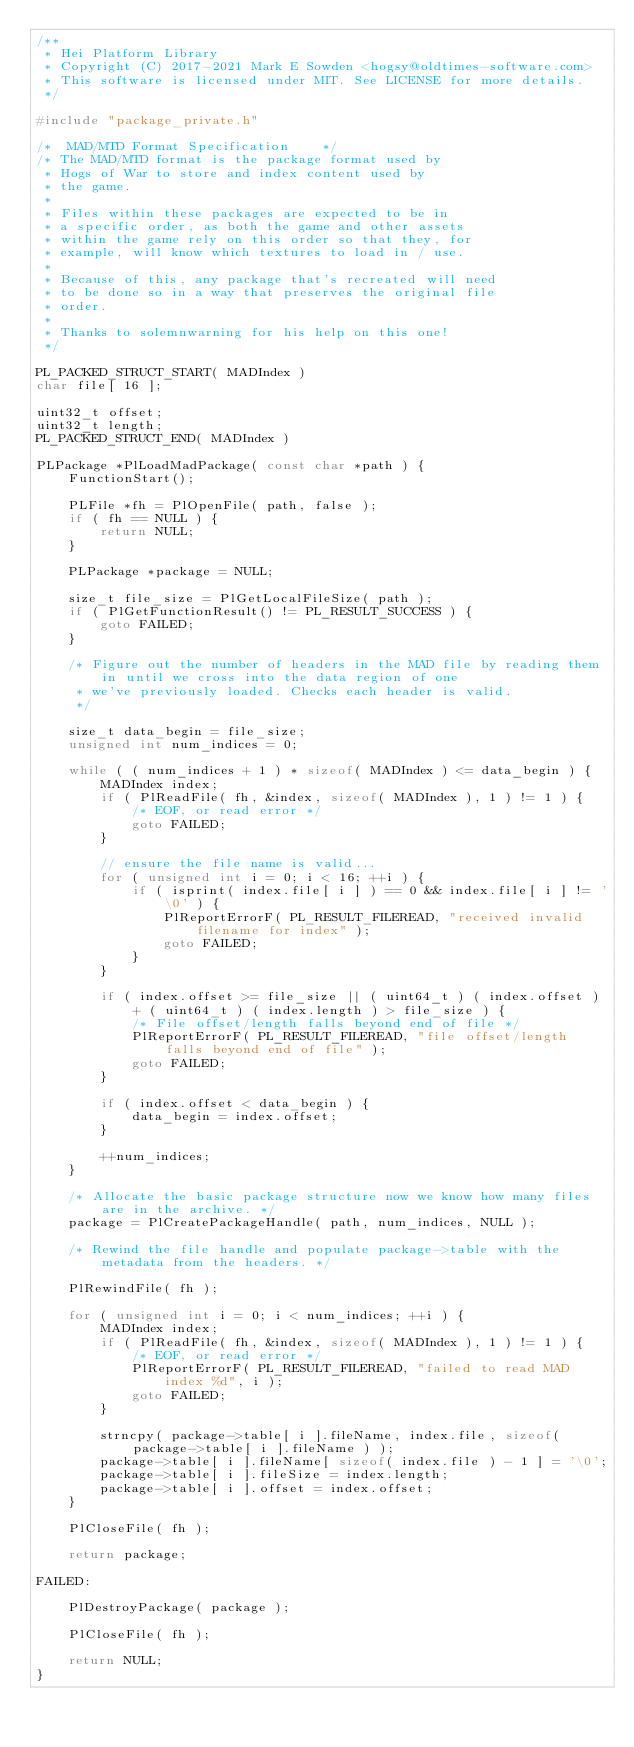<code> <loc_0><loc_0><loc_500><loc_500><_C_>/**
 * Hei Platform Library
 * Copyright (C) 2017-2021 Mark E Sowden <hogsy@oldtimes-software.com>
 * This software is licensed under MIT. See LICENSE for more details.
 */

#include "package_private.h"

/*  MAD/MTD Format Specification    */
/* The MAD/MTD format is the package format used by
 * Hogs of War to store and index content used by
 * the game.
 *
 * Files within these packages are expected to be in
 * a specific order, as both the game and other assets
 * within the game rely on this order so that they, for
 * example, will know which textures to load in / use.
 *
 * Because of this, any package that's recreated will need
 * to be done so in a way that preserves the original file
 * order.
 *
 * Thanks to solemnwarning for his help on this one!
 */

PL_PACKED_STRUCT_START( MADIndex )
char file[ 16 ];

uint32_t offset;
uint32_t length;
PL_PACKED_STRUCT_END( MADIndex )

PLPackage *PlLoadMadPackage( const char *path ) {
	FunctionStart();

	PLFile *fh = PlOpenFile( path, false );
	if ( fh == NULL ) {
		return NULL;
	}

	PLPackage *package = NULL;

	size_t file_size = PlGetLocalFileSize( path );
	if ( PlGetFunctionResult() != PL_RESULT_SUCCESS ) {
		goto FAILED;
	}

	/* Figure out the number of headers in the MAD file by reading them in until we cross into the data region of one
	 * we've previously loaded. Checks each header is valid.
	 */

	size_t data_begin = file_size;
	unsigned int num_indices = 0;

	while ( ( num_indices + 1 ) * sizeof( MADIndex ) <= data_begin ) {
		MADIndex index;
		if ( PlReadFile( fh, &index, sizeof( MADIndex ), 1 ) != 1 ) {
			/* EOF, or read error */
			goto FAILED;
		}

		// ensure the file name is valid...
		for ( unsigned int i = 0; i < 16; ++i ) {
			if ( isprint( index.file[ i ] ) == 0 && index.file[ i ] != '\0' ) {
				PlReportErrorF( PL_RESULT_FILEREAD, "received invalid filename for index" );
				goto FAILED;
			}
		}

		if ( index.offset >= file_size || ( uint64_t ) ( index.offset ) + ( uint64_t ) ( index.length ) > file_size ) {
			/* File offset/length falls beyond end of file */
			PlReportErrorF( PL_RESULT_FILEREAD, "file offset/length falls beyond end of file" );
			goto FAILED;
		}

		if ( index.offset < data_begin ) {
			data_begin = index.offset;
		}

		++num_indices;
	}

	/* Allocate the basic package structure now we know how many files are in the archive. */
	package = PlCreatePackageHandle( path, num_indices, NULL );

	/* Rewind the file handle and populate package->table with the metadata from the headers. */

	PlRewindFile( fh );

	for ( unsigned int i = 0; i < num_indices; ++i ) {
		MADIndex index;
		if ( PlReadFile( fh, &index, sizeof( MADIndex ), 1 ) != 1 ) {
			/* EOF, or read error */
			PlReportErrorF( PL_RESULT_FILEREAD, "failed to read MAD index %d", i );
			goto FAILED;
		}

		strncpy( package->table[ i ].fileName, index.file, sizeof( package->table[ i ].fileName ) );
		package->table[ i ].fileName[ sizeof( index.file ) - 1 ] = '\0';
		package->table[ i ].fileSize = index.length;
		package->table[ i ].offset = index.offset;
	}

	PlCloseFile( fh );

	return package;

FAILED:

	PlDestroyPackage( package );

	PlCloseFile( fh );

	return NULL;
}
</code> 